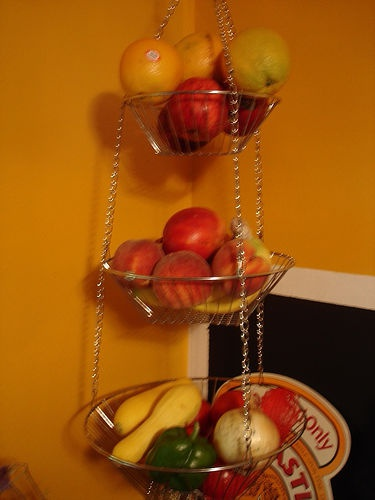Describe the objects in this image and their specific colors. I can see apple in brown, olive, maroon, and orange tones, apple in brown and maroon tones, orange in brown, olive, and maroon tones, orange in brown, red, orange, and maroon tones, and apple in brown, maroon, and red tones in this image. 